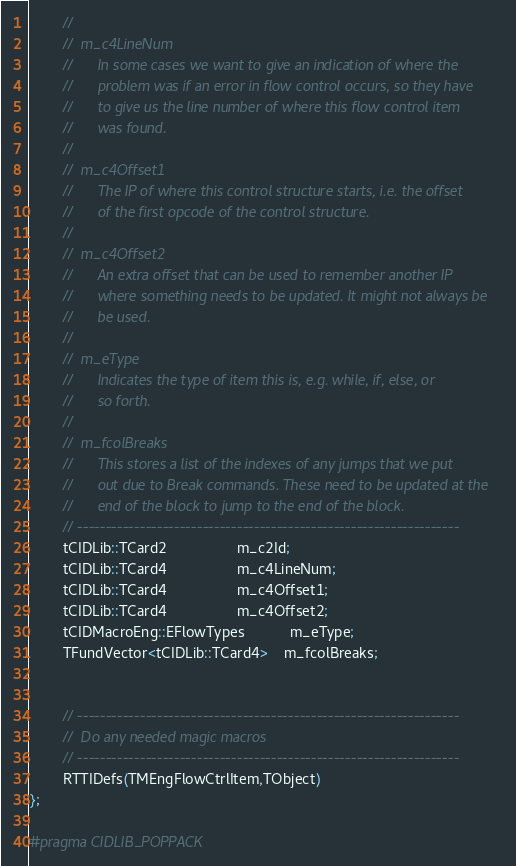Convert code to text. <code><loc_0><loc_0><loc_500><loc_500><_C++_>        //
        //  m_c4LineNum
        //      In some cases we want to give an indication of where the
        //      problem was if an error in flow control occurs, so they have
        //      to give us the line number of where this flow control item
        //      was found.
        //
        //  m_c4Offset1
        //      The IP of where this control structure starts, i.e. the offset
        //      of the first opcode of the control structure.
        //
        //  m_c4Offset2
        //      An extra offset that can be used to remember another IP
        //      where something needs to be updated. It might not always be
        //      be used.
        //
        //  m_eType
        //      Indicates the type of item this is, e.g. while, if, else, or
        //      so forth.
        //
        //  m_fcolBreaks
        //      This stores a list of the indexes of any jumps that we put
        //      out due to Break commands. These need to be updated at the
        //      end of the block to jump to the end of the block.
        // -------------------------------------------------------------------
        tCIDLib::TCard2                 m_c2Id;
        tCIDLib::TCard4                 m_c4LineNum;
        tCIDLib::TCard4                 m_c4Offset1;
        tCIDLib::TCard4                 m_c4Offset2;
        tCIDMacroEng::EFlowTypes           m_eType;
        TFundVector<tCIDLib::TCard4>    m_fcolBreaks;


        // -------------------------------------------------------------------
        //  Do any needed magic macros
        // -------------------------------------------------------------------
        RTTIDefs(TMEngFlowCtrlItem,TObject)
};

#pragma CIDLIB_POPPACK


</code> 